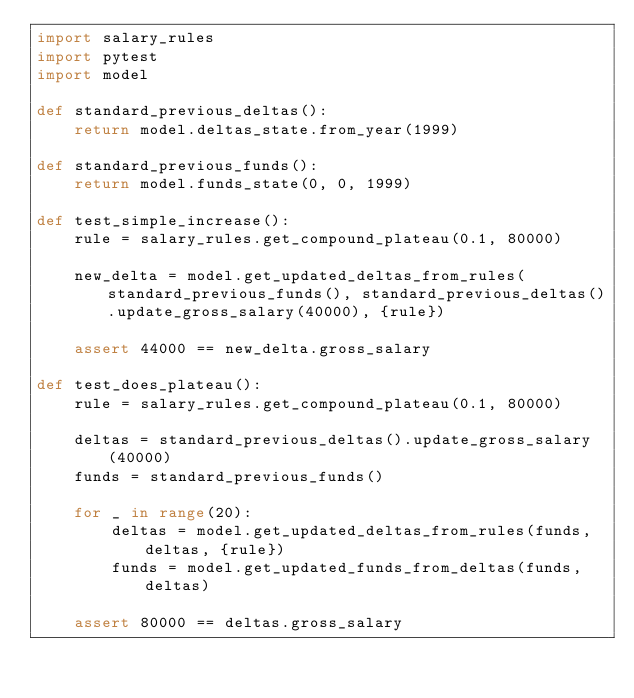<code> <loc_0><loc_0><loc_500><loc_500><_Python_>import salary_rules
import pytest
import model

def standard_previous_deltas():
    return model.deltas_state.from_year(1999)

def standard_previous_funds():
    return model.funds_state(0, 0, 1999)

def test_simple_increase():
    rule = salary_rules.get_compound_plateau(0.1, 80000)

    new_delta = model.get_updated_deltas_from_rules(standard_previous_funds(), standard_previous_deltas().update_gross_salary(40000), {rule})

    assert 44000 == new_delta.gross_salary

def test_does_plateau():
    rule = salary_rules.get_compound_plateau(0.1, 80000)

    deltas = standard_previous_deltas().update_gross_salary(40000)
    funds = standard_previous_funds()

    for _ in range(20):
        deltas = model.get_updated_deltas_from_rules(funds, deltas, {rule})
        funds = model.get_updated_funds_from_deltas(funds, deltas)

    assert 80000 == deltas.gross_salary
</code> 